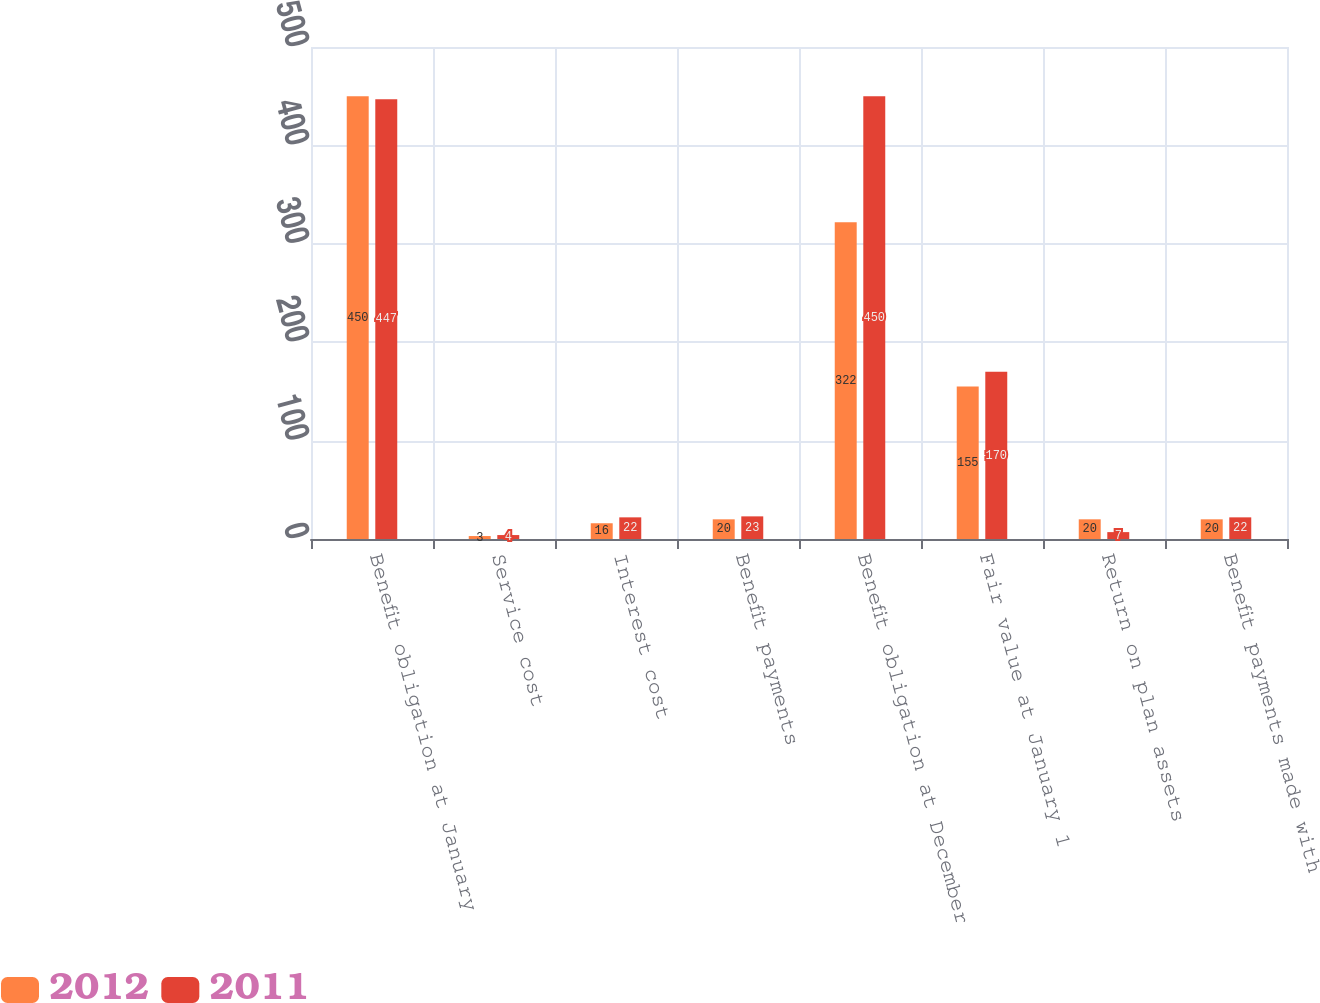Convert chart to OTSL. <chart><loc_0><loc_0><loc_500><loc_500><stacked_bar_chart><ecel><fcel>Benefit obligation at January<fcel>Service cost<fcel>Interest cost<fcel>Benefit payments<fcel>Benefit obligation at December<fcel>Fair value at January 1<fcel>Return on plan assets<fcel>Benefit payments made with<nl><fcel>2012<fcel>450<fcel>3<fcel>16<fcel>20<fcel>322<fcel>155<fcel>20<fcel>20<nl><fcel>2011<fcel>447<fcel>4<fcel>22<fcel>23<fcel>450<fcel>170<fcel>7<fcel>22<nl></chart> 